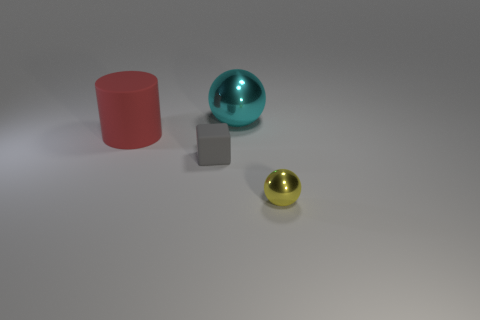Add 4 tiny gray objects. How many objects exist? 8 Subtract all blocks. How many objects are left? 3 Subtract 1 gray blocks. How many objects are left? 3 Subtract all cylinders. Subtract all tiny yellow metallic things. How many objects are left? 2 Add 3 gray blocks. How many gray blocks are left? 4 Add 2 big brown matte cubes. How many big brown matte cubes exist? 2 